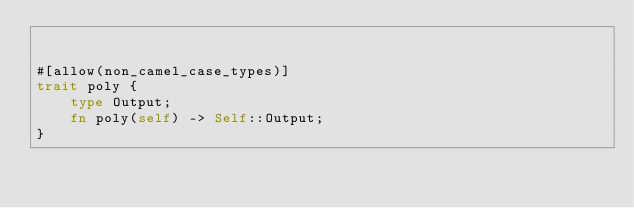Convert code to text. <code><loc_0><loc_0><loc_500><loc_500><_Rust_>

#[allow(non_camel_case_types)]
trait poly {
    type Output;
    fn poly(self) -> Self::Output;
}
</code> 